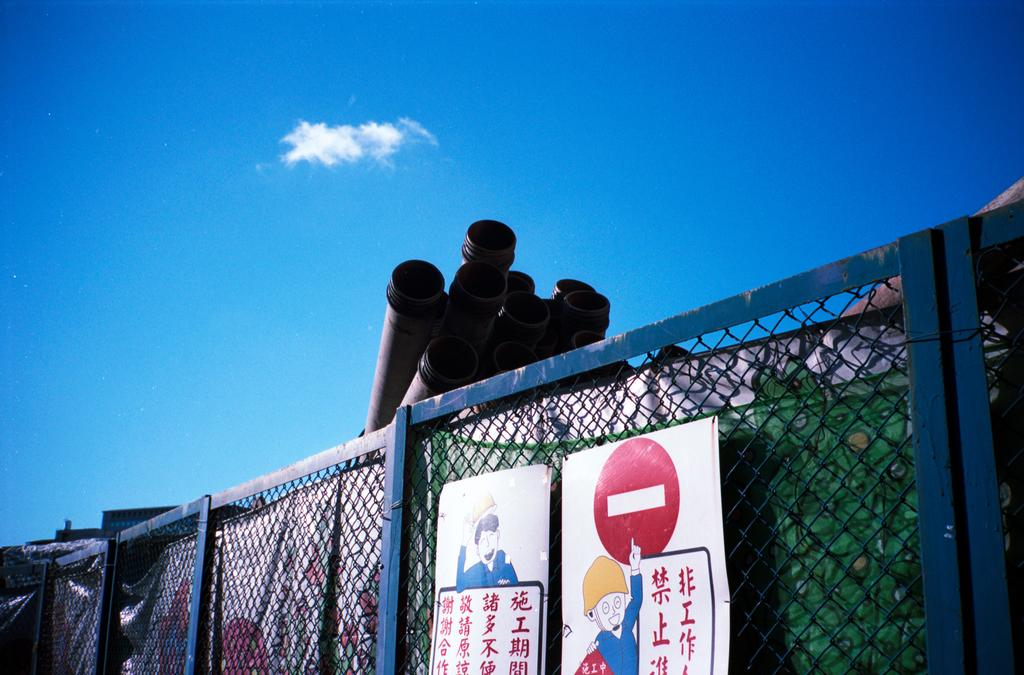What is the main feature of the image? The main feature of the image is a mesh. What is attached to the mesh? There are two posters attached to the mesh. What else can be seen behind the mesh? Pipes are visible behind the mesh. How many buttons can be seen on the mesh in the image? There are no buttons visible on the mesh in the image. Can you describe the kiss between the two posters in the image? There is no kiss depicted between the two posters in the image. 